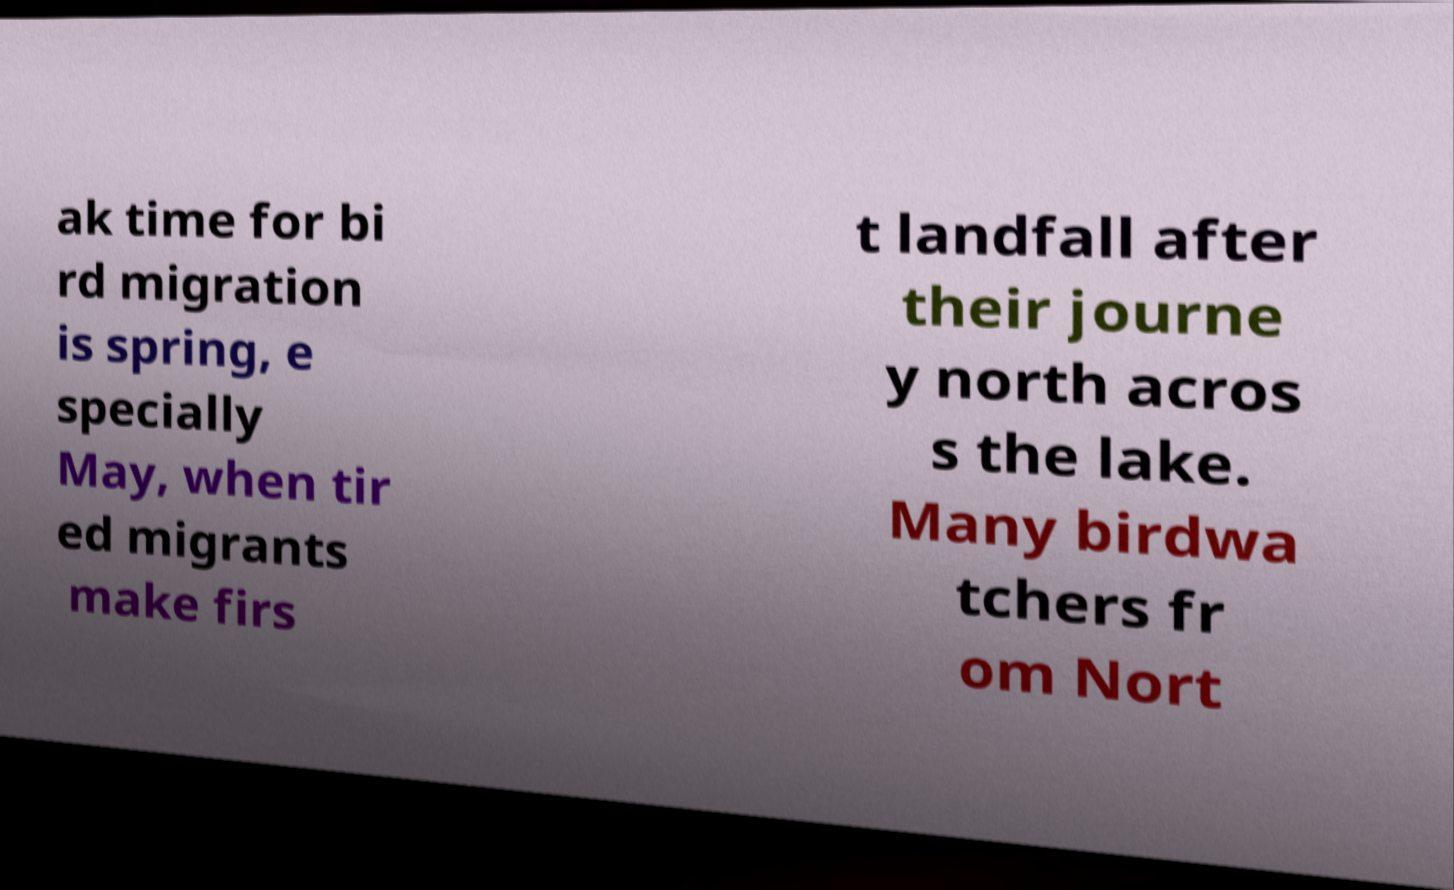Can you accurately transcribe the text from the provided image for me? ak time for bi rd migration is spring, e specially May, when tir ed migrants make firs t landfall after their journe y north acros s the lake. Many birdwa tchers fr om Nort 